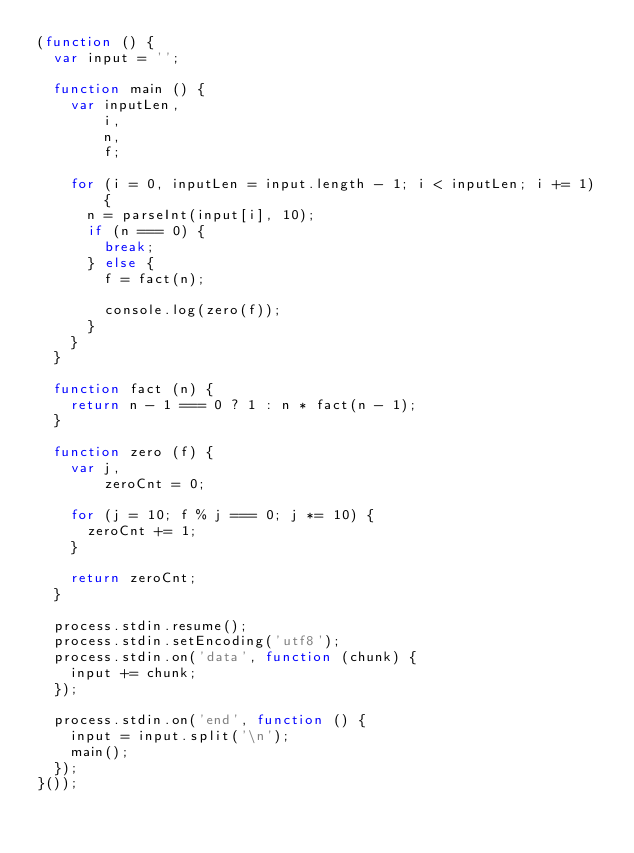Convert code to text. <code><loc_0><loc_0><loc_500><loc_500><_JavaScript_>(function () {
  var input = '';

  function main () {
    var inputLen,
        i,
        n,
        f;
    
    for (i = 0, inputLen = input.length - 1; i < inputLen; i += 1) {
      n = parseInt(input[i], 10);
      if (n === 0) {
        break;
      } else {
        f = fact(n);

        console.log(zero(f));
      }
    }
  }

  function fact (n) {
    return n - 1 === 0 ? 1 : n * fact(n - 1);
  }

  function zero (f) {
    var j,
        zeroCnt = 0;

    for (j = 10; f % j === 0; j *= 10) {
      zeroCnt += 1;
    }

    return zeroCnt;
  }
  
  process.stdin.resume();
  process.stdin.setEncoding('utf8');
  process.stdin.on('data', function (chunk) {
    input += chunk;
  });

  process.stdin.on('end', function () {
    input = input.split('\n');
    main();
  });
}());</code> 